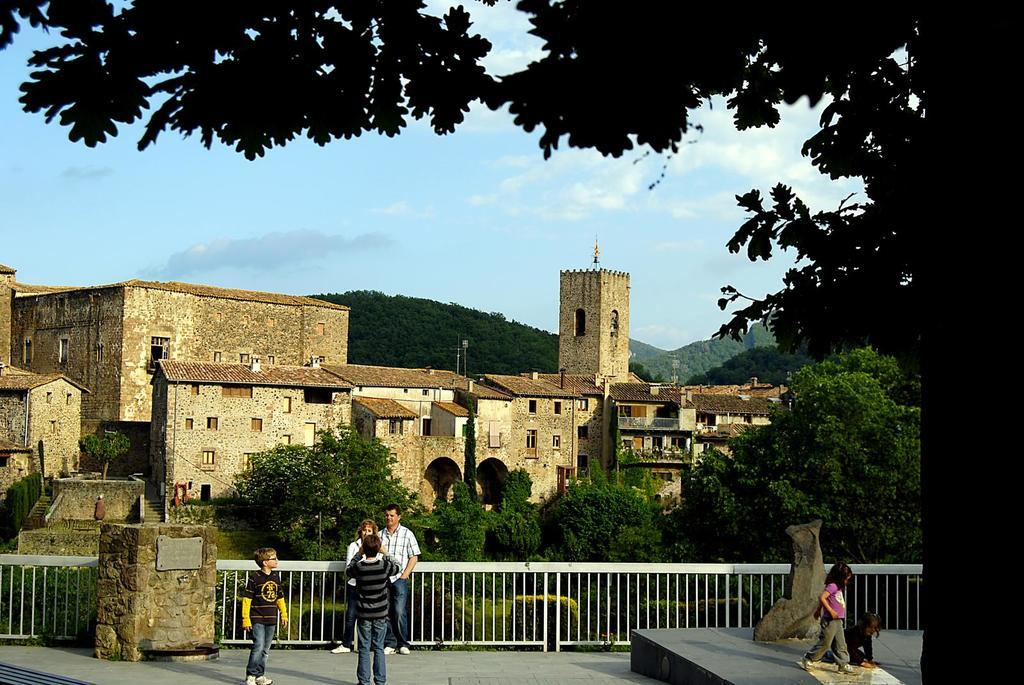What can be seen in the image? There are people standing in the image. What is visible in the background of the image? There are trees, buildings, mountains, clouds, and the sky visible in the background of the image. What type of silk is being used for the activity in the image? There is no silk or activity involving silk present in the image. 